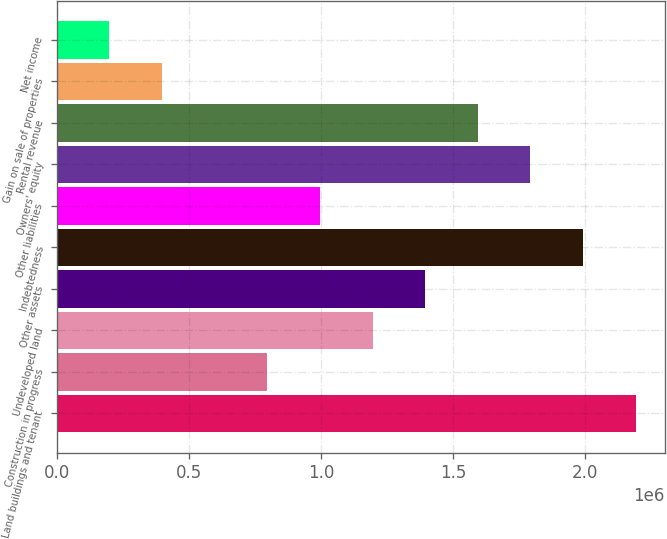Convert chart. <chart><loc_0><loc_0><loc_500><loc_500><bar_chart><fcel>Land buildings and tenant<fcel>Construction in progress<fcel>Undeveloped land<fcel>Other assets<fcel>Indebtedness<fcel>Other liabilities<fcel>Owners' equity<fcel>Rental revenue<fcel>Gain on sale of properties<fcel>Net income<nl><fcel>2.191e+06<fcel>796785<fcel>1.19513e+06<fcel>1.3943e+06<fcel>1.99182e+06<fcel>995958<fcel>1.79265e+06<fcel>1.59348e+06<fcel>398438<fcel>199265<nl></chart> 